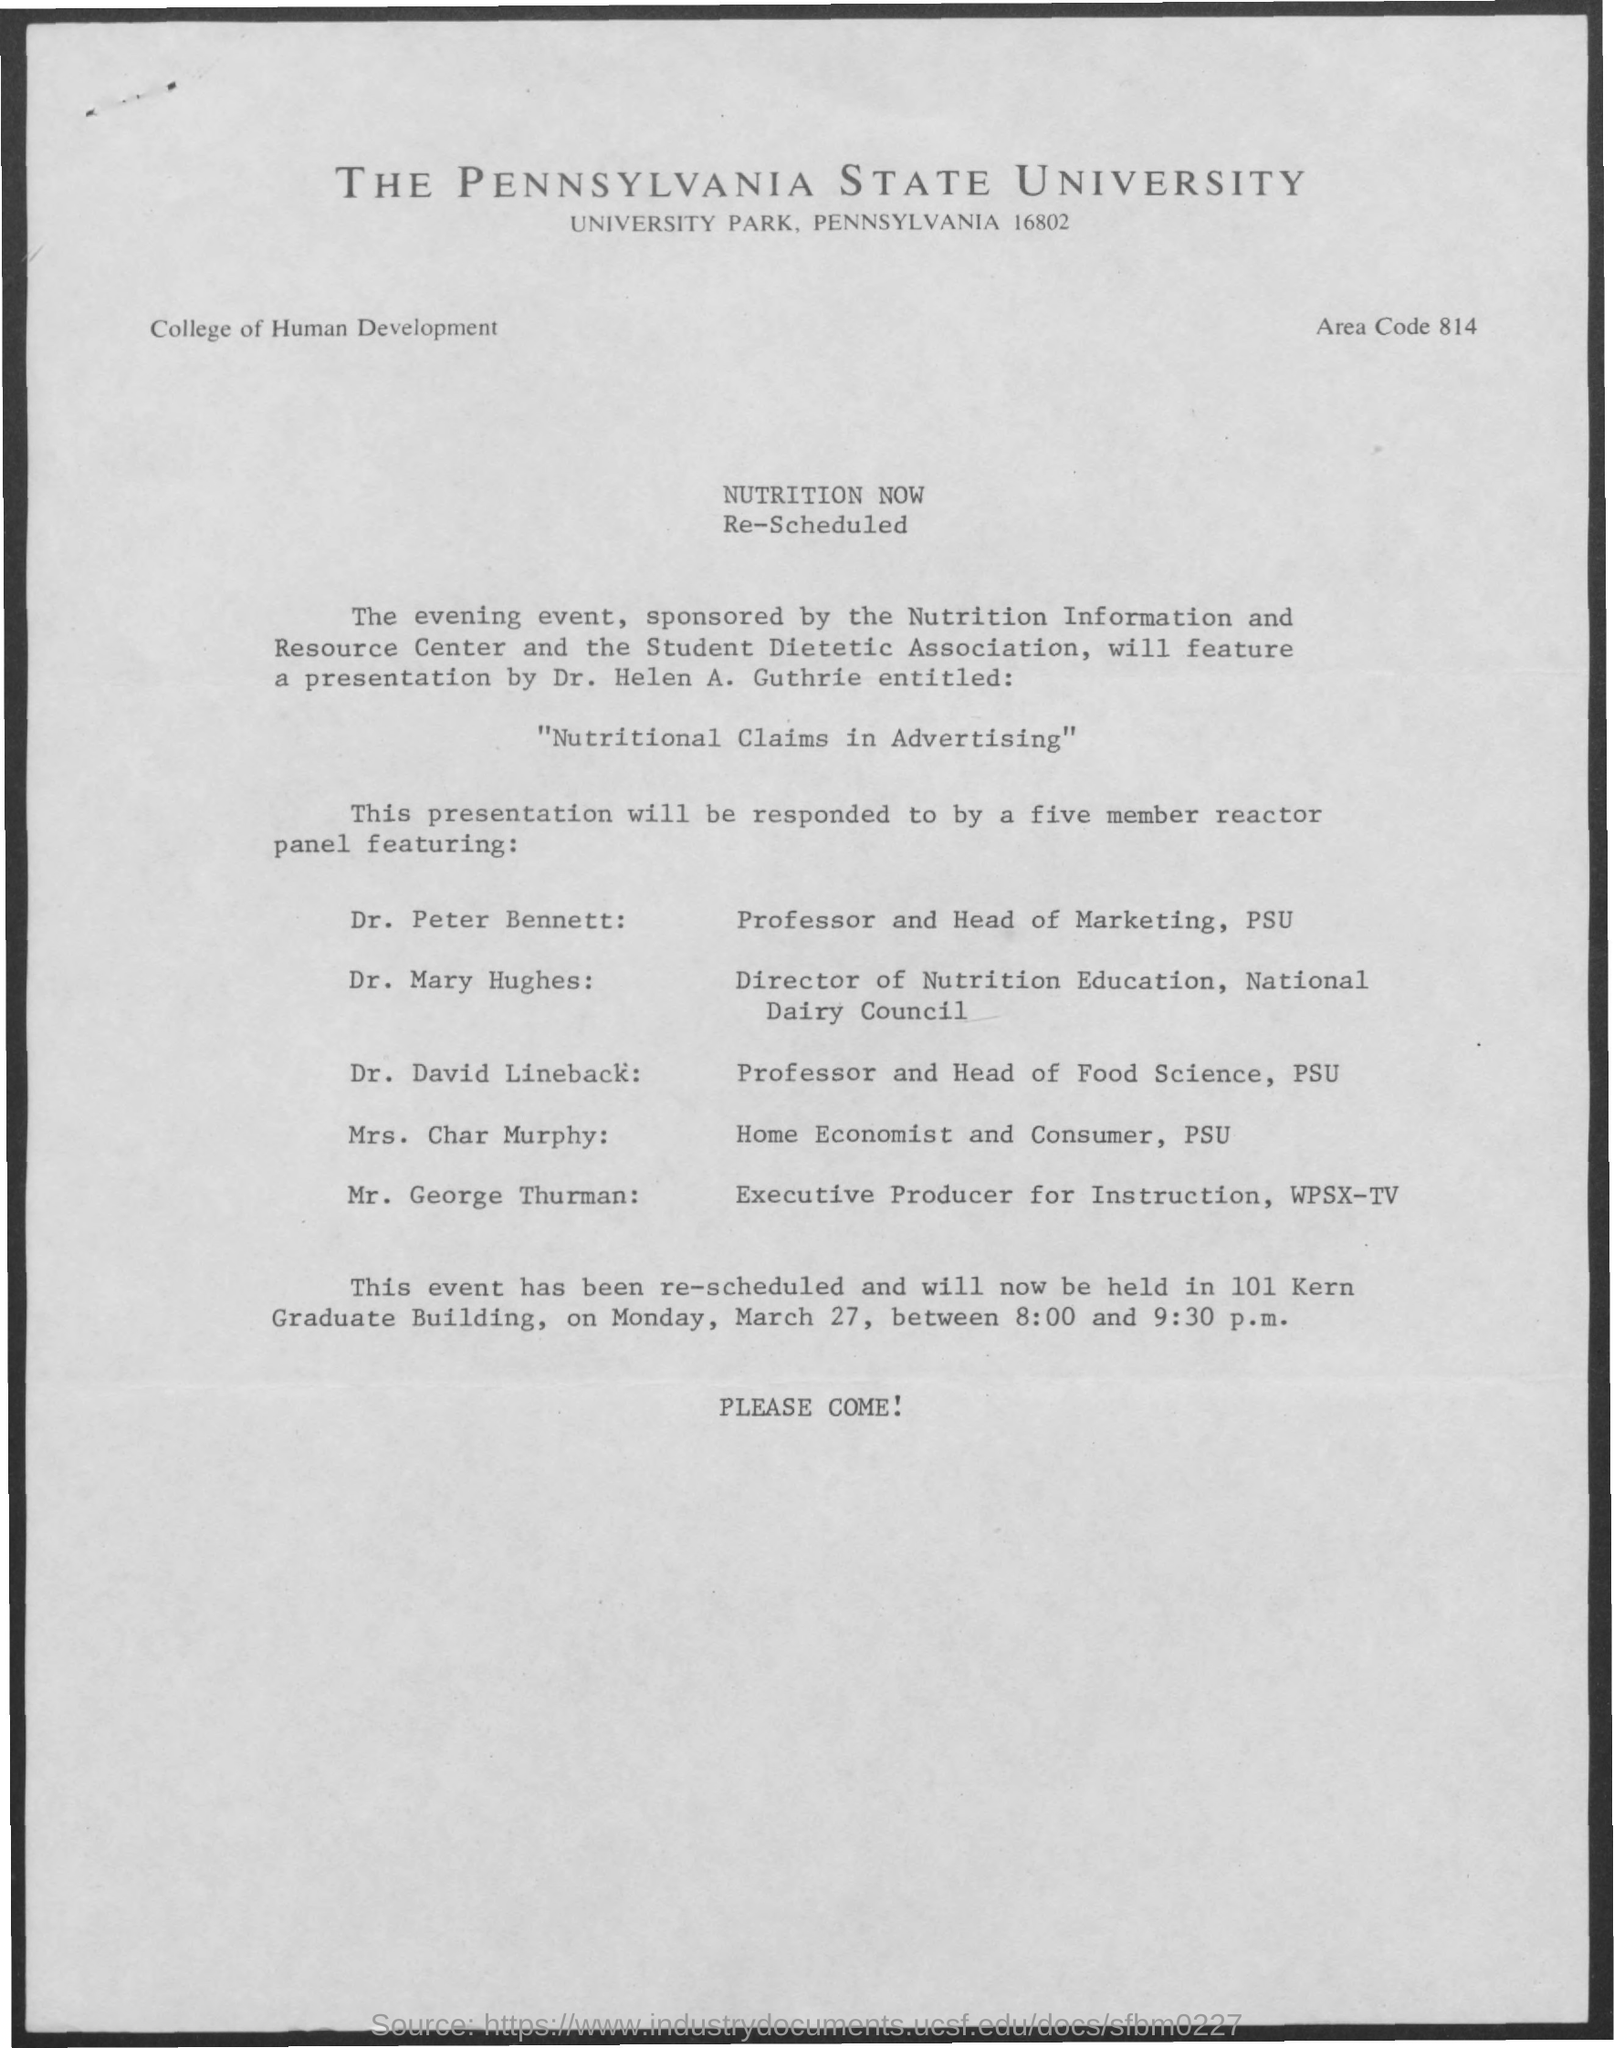Specify some key components in this picture. The presentation given by Dr. Helen A. Guthrie is named "Nutritional Claims in Advertising. 